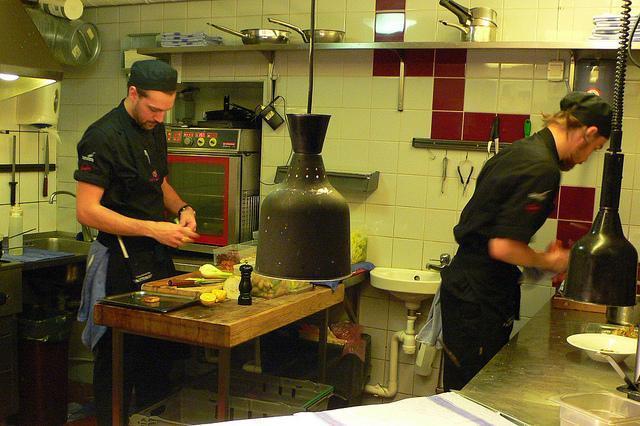How many people are there?
Give a very brief answer. 2. How many dining tables are visible?
Give a very brief answer. 1. How many scissors are in blue color?
Give a very brief answer. 0. 